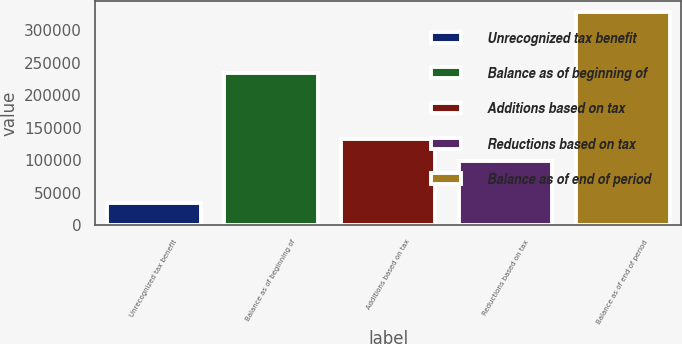<chart> <loc_0><loc_0><loc_500><loc_500><bar_chart><fcel>Unrecognized tax benefit<fcel>Balance as of beginning of<fcel>Additions based on tax<fcel>Reductions based on tax<fcel>Balance as of end of period<nl><fcel>34460.2<fcel>235067<fcel>132624<fcel>99902.6<fcel>328951<nl></chart> 